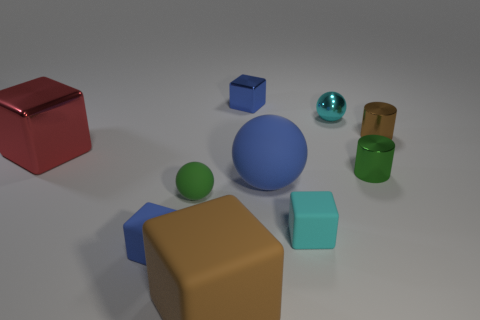What is the material of the green thing that is the same shape as the tiny brown thing?
Your answer should be very brief. Metal. Is there anything else that has the same material as the cyan cube?
Provide a succinct answer. Yes. There is a small thing that is both to the right of the cyan matte block and left of the small green metal thing; what is it made of?
Your response must be concise. Metal. How many brown matte objects are the same shape as the small green matte object?
Ensure brevity in your answer.  0. The tiny block that is behind the large block that is behind the green metallic thing is what color?
Offer a terse response. Blue. Are there the same number of large blue objects that are in front of the big blue thing and metal cubes?
Your response must be concise. No. Is there a sphere that has the same size as the cyan metal object?
Your response must be concise. Yes. Does the green rubber thing have the same size as the blue cube left of the brown matte object?
Keep it short and to the point. Yes. Are there an equal number of cyan cubes that are behind the cyan rubber block and tiny cyan shiny spheres in front of the small cyan metallic thing?
Your answer should be very brief. Yes. What is the shape of the small thing that is the same color as the big rubber block?
Your response must be concise. Cylinder. 